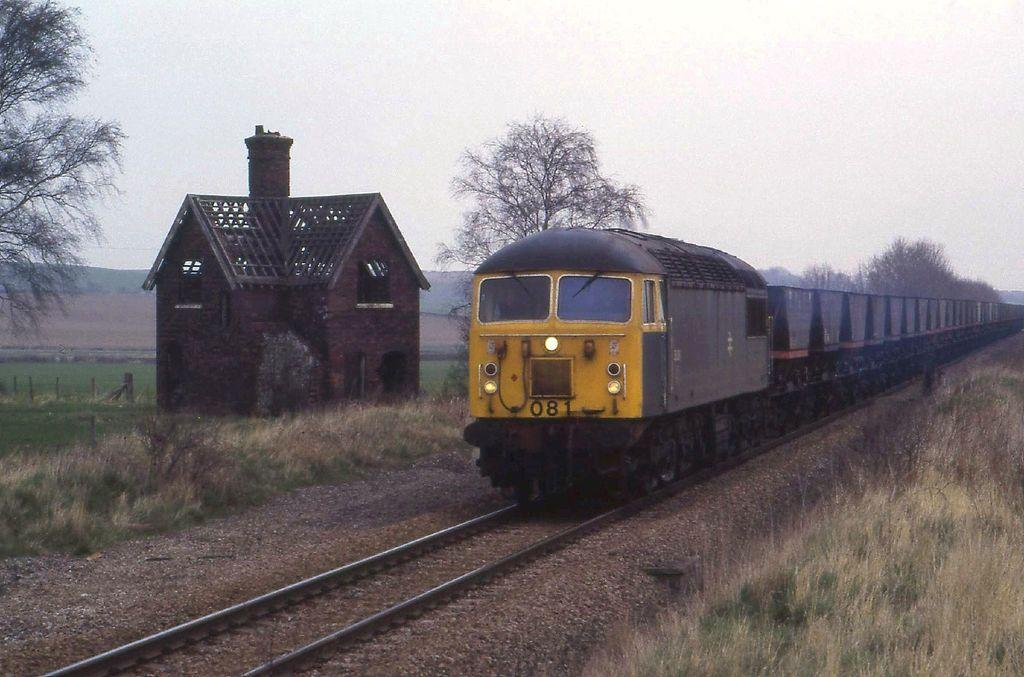What is the main subject of the image? There is a train in the image. Where is the train located? The train is on a railway track. What other structures or objects can be seen in the image? There is a shed, trees, grass, and a fence visible in the image. What is visible in the background of the image? The sky is visible in the background of the image. What type of pickle is being smashed in the competition shown in the image? There is no pickle or competition present in the image. The image features a train on a railway track, a shed, trees, grass, a fence, and the sky in the background. 